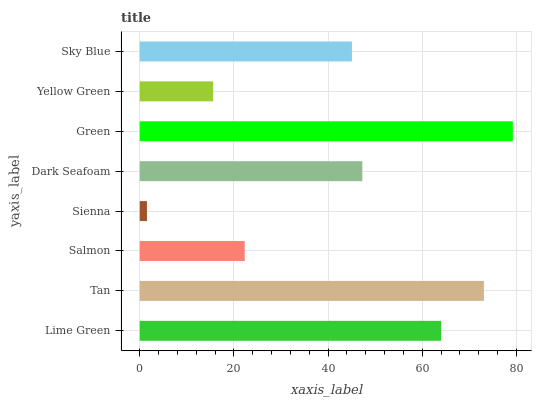Is Sienna the minimum?
Answer yes or no. Yes. Is Green the maximum?
Answer yes or no. Yes. Is Tan the minimum?
Answer yes or no. No. Is Tan the maximum?
Answer yes or no. No. Is Tan greater than Lime Green?
Answer yes or no. Yes. Is Lime Green less than Tan?
Answer yes or no. Yes. Is Lime Green greater than Tan?
Answer yes or no. No. Is Tan less than Lime Green?
Answer yes or no. No. Is Dark Seafoam the high median?
Answer yes or no. Yes. Is Sky Blue the low median?
Answer yes or no. Yes. Is Yellow Green the high median?
Answer yes or no. No. Is Yellow Green the low median?
Answer yes or no. No. 